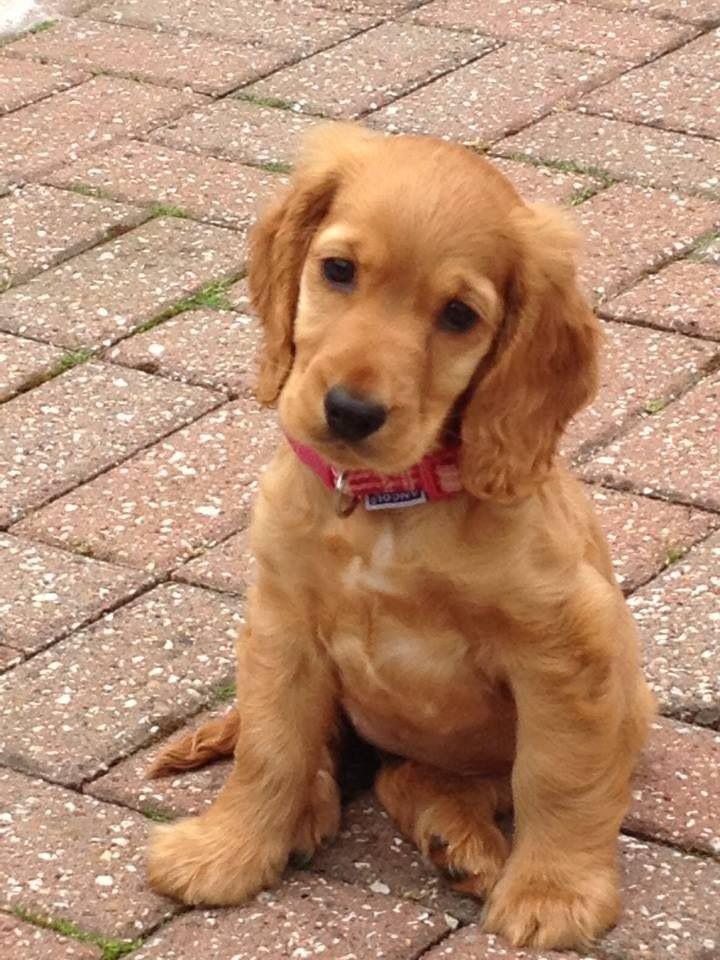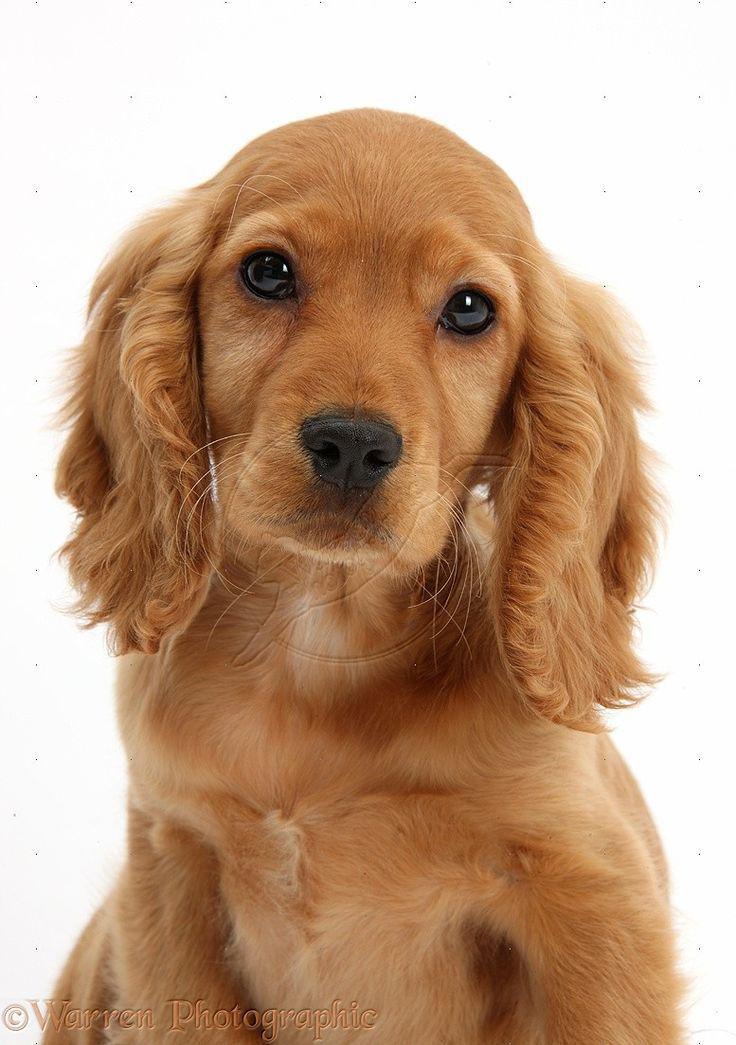The first image is the image on the left, the second image is the image on the right. Given the left and right images, does the statement "There's at least two dogs in the right image." hold true? Answer yes or no. No. The first image is the image on the left, the second image is the image on the right. Evaluate the accuracy of this statement regarding the images: "One image shows a golden-haired puppy posing with an animal that is not a puppy.". Is it true? Answer yes or no. No. 